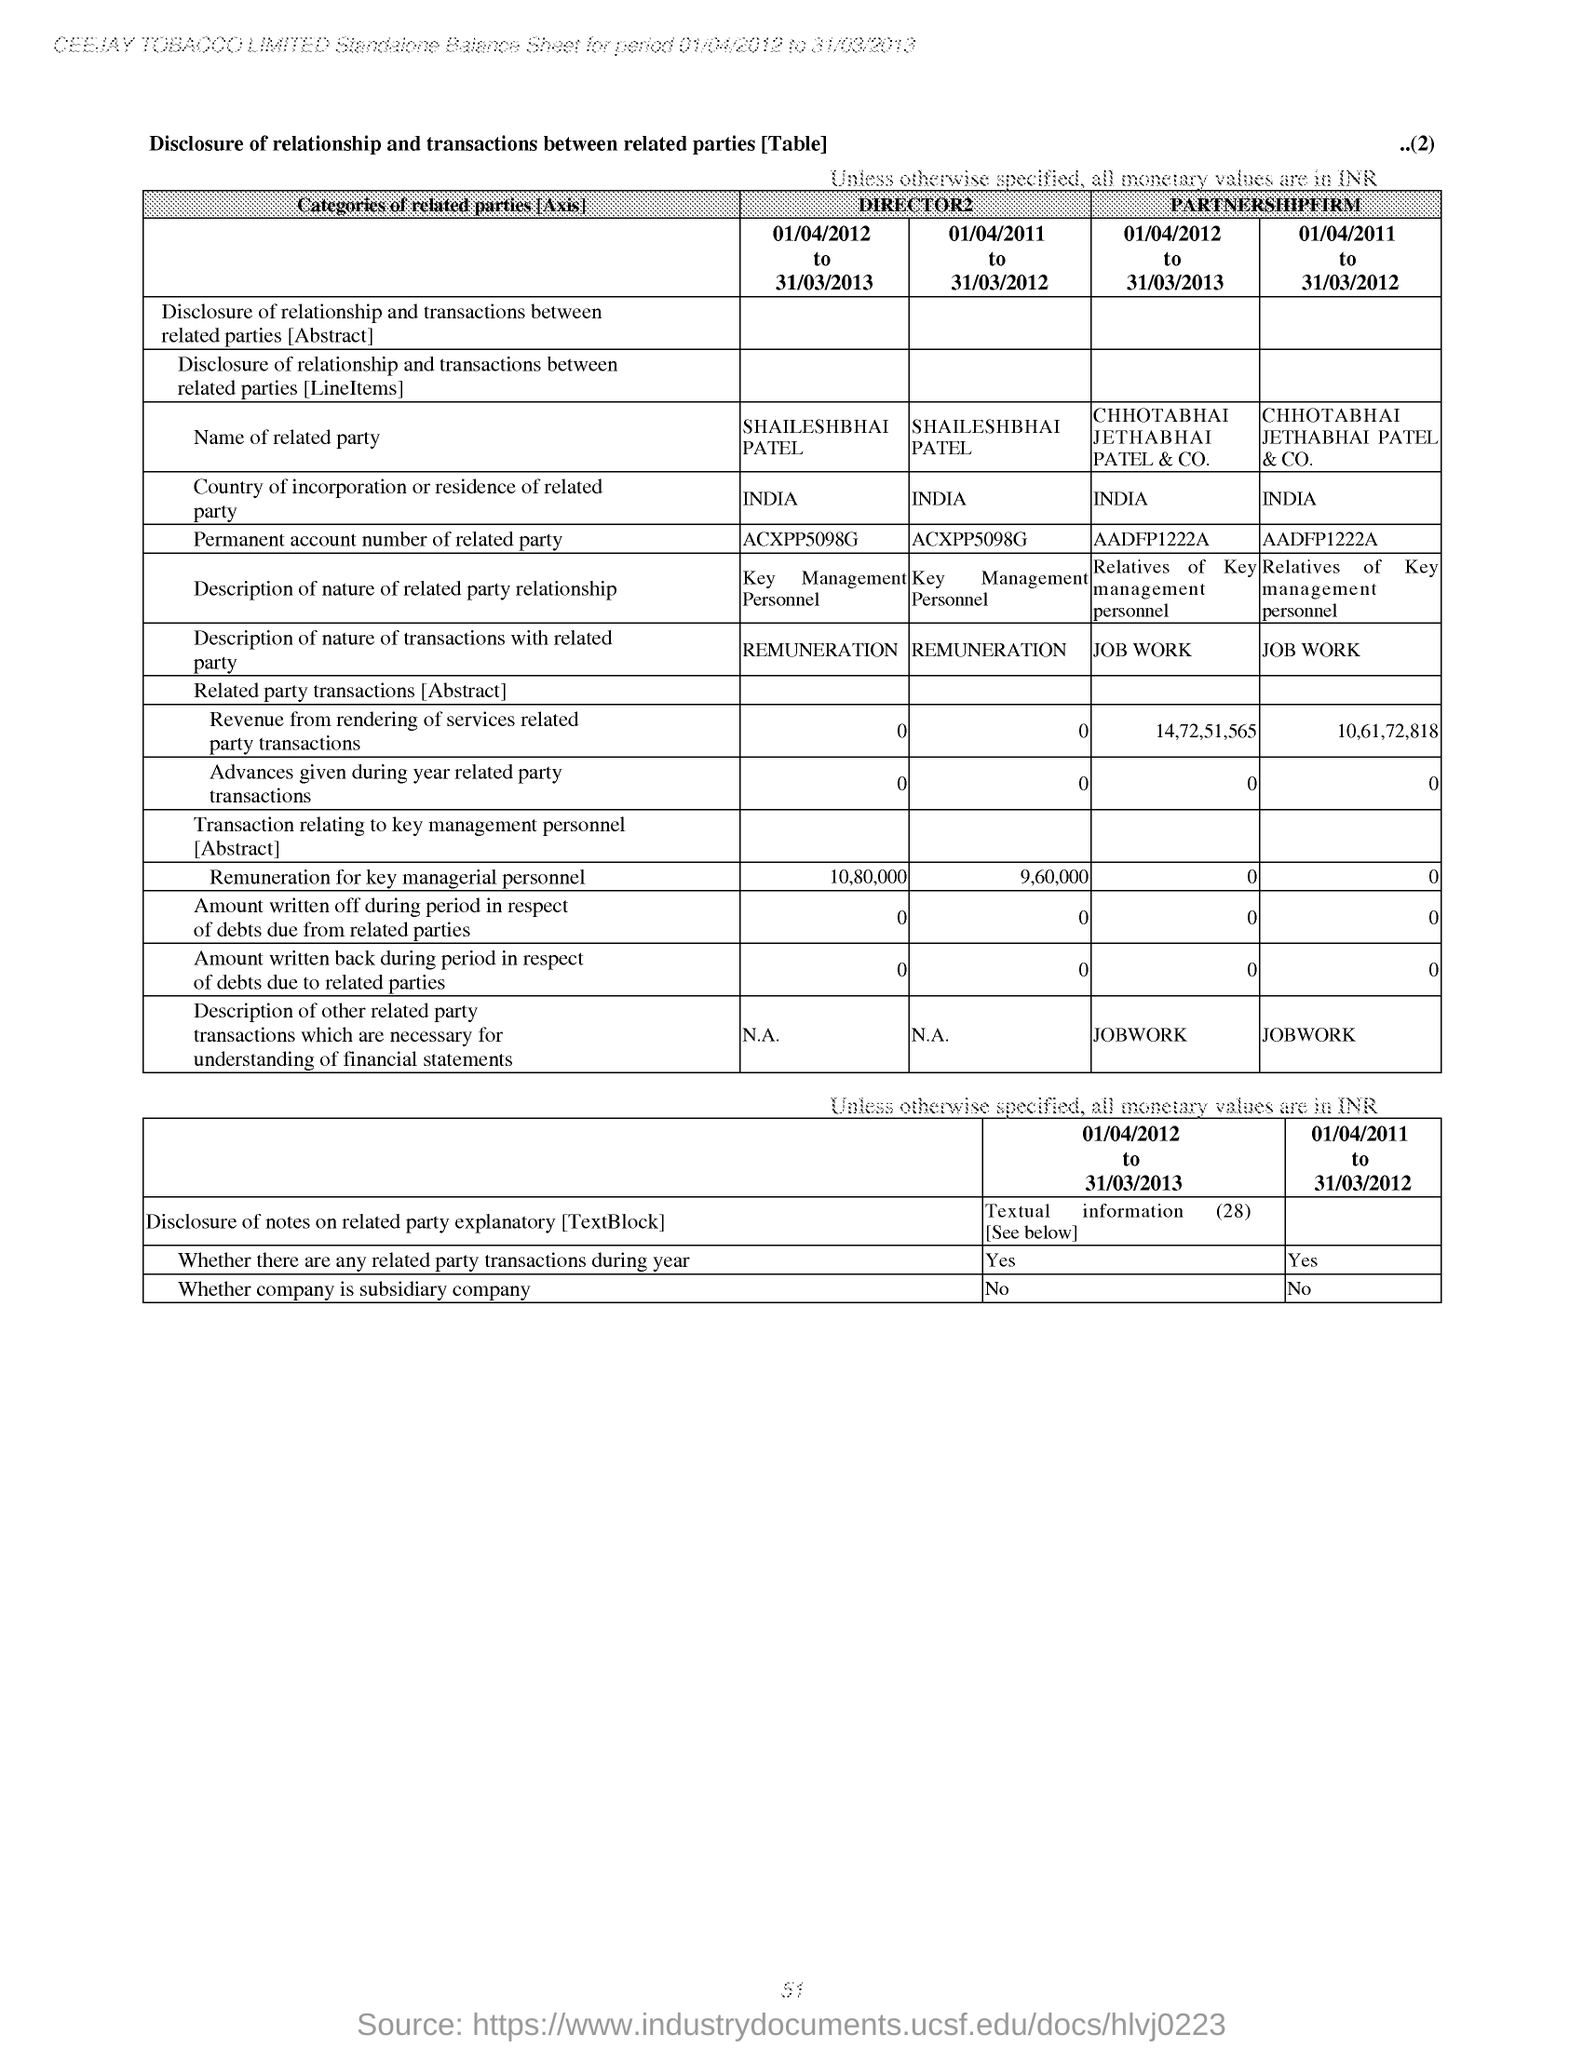Is the company subsidiary company?
Offer a terse response. No. 